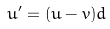Convert formula to latex. <formula><loc_0><loc_0><loc_500><loc_500>u ^ { \prime } = ( u - v ) d</formula> 